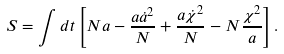<formula> <loc_0><loc_0><loc_500><loc_500>S = \int d t \left [ N a - \frac { a \dot { a } ^ { 2 } } { N } + \frac { a \dot { \chi } ^ { 2 } } { N } - N \frac { \chi ^ { 2 } } { a } \right ] .</formula> 